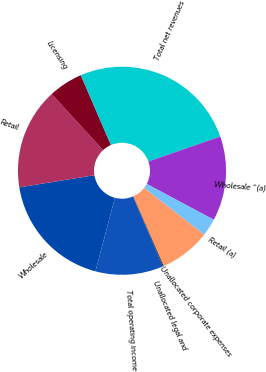Convert chart. <chart><loc_0><loc_0><loc_500><loc_500><pie_chart><fcel>Wholesale<fcel>Retail<fcel>Licensing<fcel>Total net revenues<fcel>Wholesale ^(a)<fcel>Retail (a)<fcel>Unallocated corporate expenses<fcel>Unallocated legal and<fcel>Total operating income<nl><fcel>18.34%<fcel>15.74%<fcel>5.33%<fcel>26.15%<fcel>13.14%<fcel>2.72%<fcel>7.93%<fcel>0.12%<fcel>10.53%<nl></chart> 